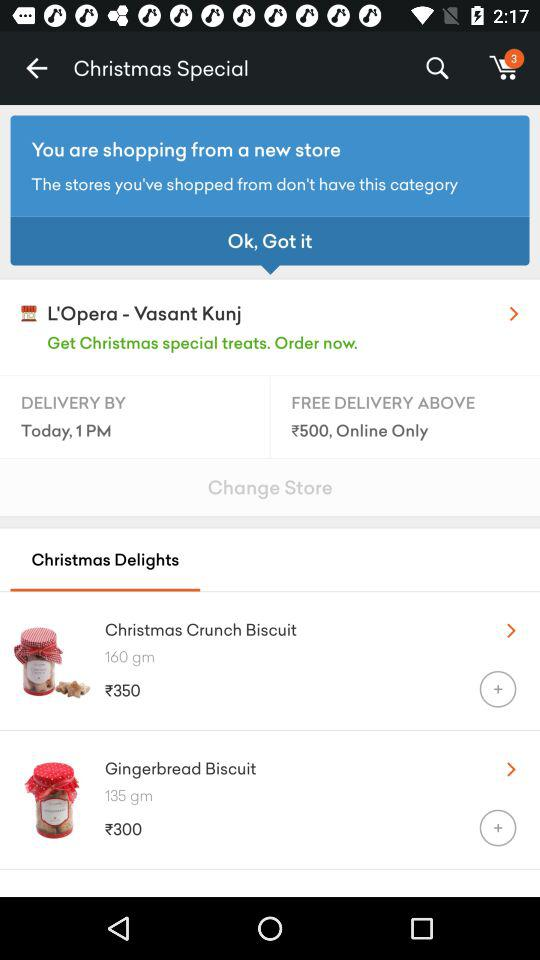When will the things be delivered? The things will be delivered by 1 PM. 